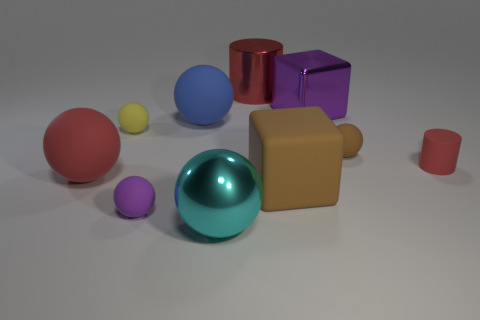What could be the purpose of these objects? These objects seem to be simple geometric solids, potentially used as visual aids for educational purposes, to teach about shapes and volume, or could be part of a 3D rendering test. 